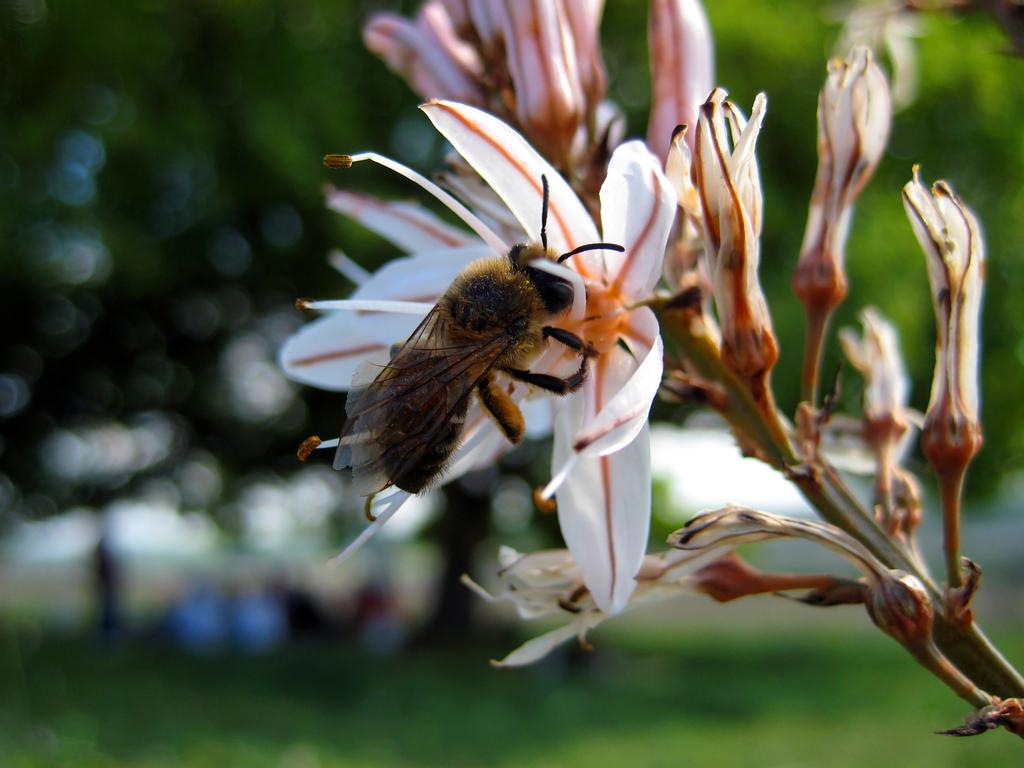What type of creature is in the image? There is an insect in the image. Where is the insect located? The insect is on a flower. What can be seen in the background of the image? There is greenery in the background of the image. What type of support can be seen in the image? There is no support visible in the image; it features an insect on a flower with greenery in the background. How many knots are tied in the image? There are no knots present in the image. 